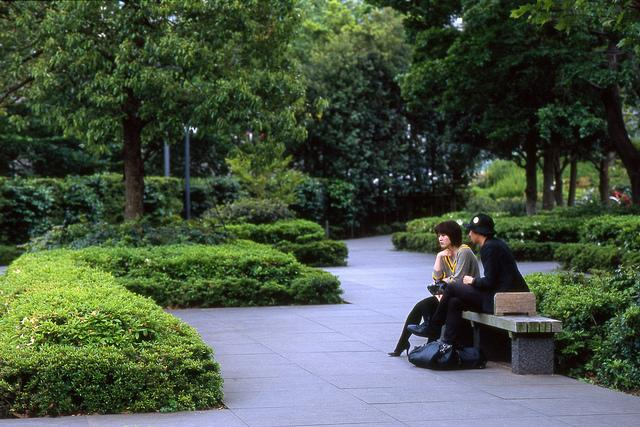How many people are sitting on the bench in the middle of the park? Please explain your reasoning. two. A man and woman are sitting together on a bench. 